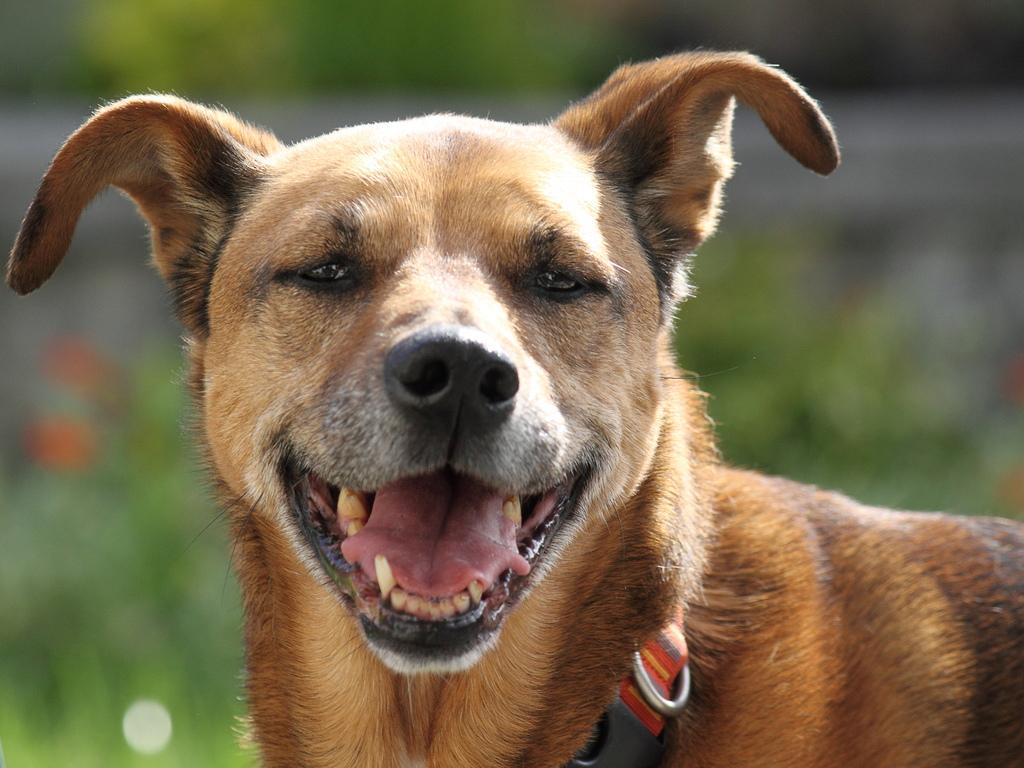How would you summarize this image in a sentence or two? In this image I can see there is a dog in the foreground and smiling at someone 